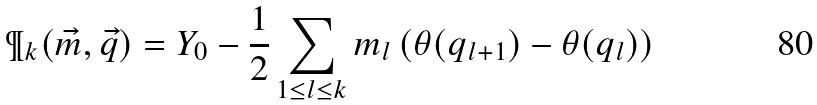<formula> <loc_0><loc_0><loc_500><loc_500>\P _ { k } ( \vec { m } , \vec { q } ) = Y _ { 0 } - \frac { 1 } { 2 } \sum _ { 1 \leq l \leq k } m _ { l } \left ( \theta ( q _ { l + 1 } ) - \theta ( q _ { l } ) \right )</formula> 